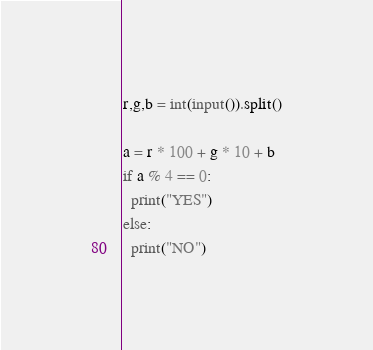Convert code to text. <code><loc_0><loc_0><loc_500><loc_500><_Python_>r,g,b = int(input()).split()

a = r * 100 + g * 10 + b
if a % 4 == 0:
  print("YES")
else:
  print("NO")</code> 